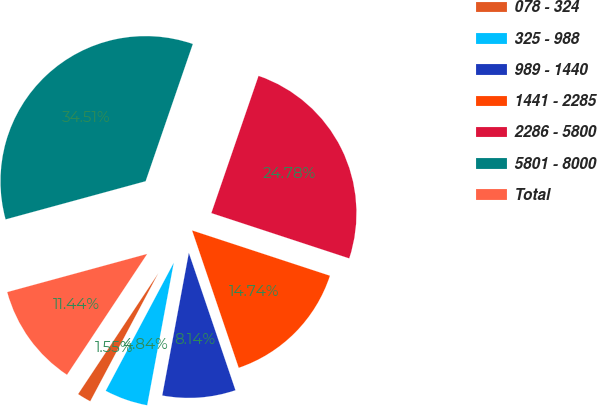Convert chart. <chart><loc_0><loc_0><loc_500><loc_500><pie_chart><fcel>078 - 324<fcel>325 - 988<fcel>989 - 1440<fcel>1441 - 2285<fcel>2286 - 5800<fcel>5801 - 8000<fcel>Total<nl><fcel>1.55%<fcel>4.84%<fcel>8.14%<fcel>14.74%<fcel>24.78%<fcel>34.51%<fcel>11.44%<nl></chart> 